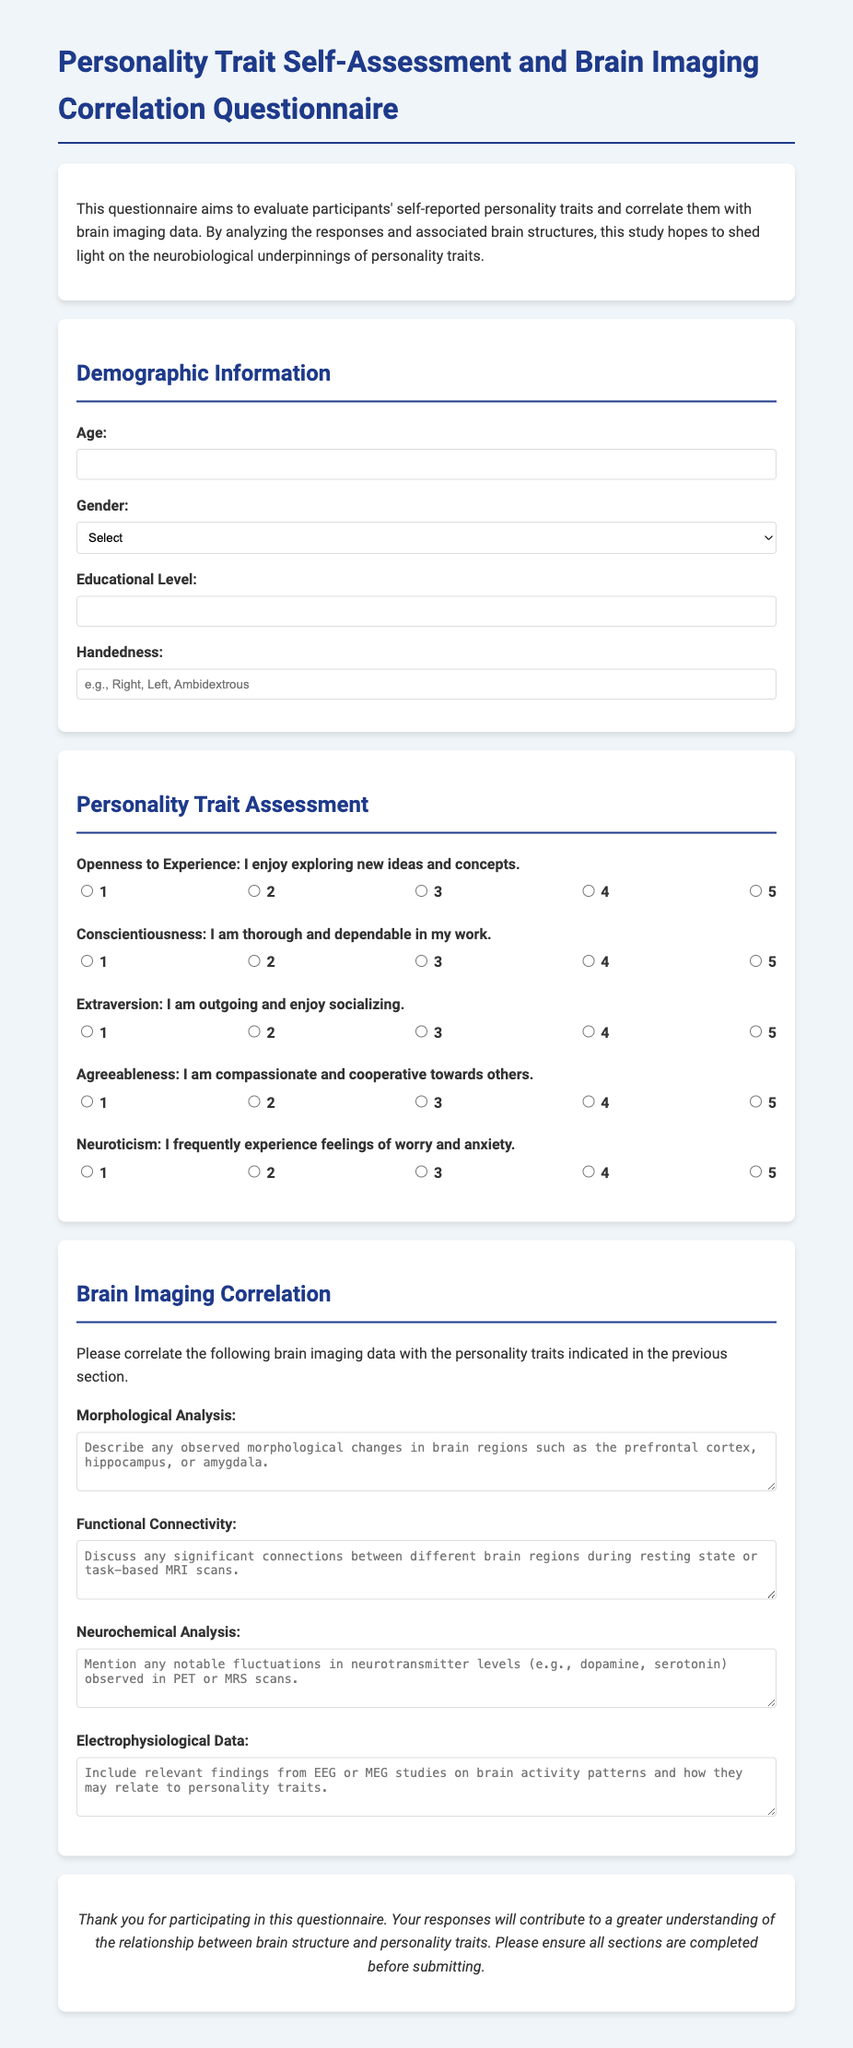What is the title of the questionnaire? The title of the questionnaire is mentioned in the document header.
Answer: Personality Trait Self-Assessment and Brain Imaging Correlation Questionnaire How many personality traits are assessed in the questionnaire? The document lists five personality traits in the assessment section.
Answer: 5 What is the required response for the question about age? The document specifies that the age response must be a number.
Answer: Required Which brain imaging data aspect asks for descriptions of neurotransmitter levels? The document includes a section that specifically requests information on neurochemical analysis.
Answer: Neurochemical Analysis What is the purpose of the questionnaire? The purpose is outlined in the introductory paragraph of the document.
Answer: To evaluate participants' self-reported personality traits and correlate them with brain imaging data What is the maximum rating scale available for each personality trait? The document indicates that responses can be rated on a scale of 1 to 5.
Answer: 5 What type of data is requested in the functional connectivity section? The questionnaire asks for significant connections between brain regions during specific conditions.
Answer: Significant connections What should be included in the morphological analysis question? The question asks participants to describe observed morphological changes in brain regions.
Answer: Observed morphological changes 